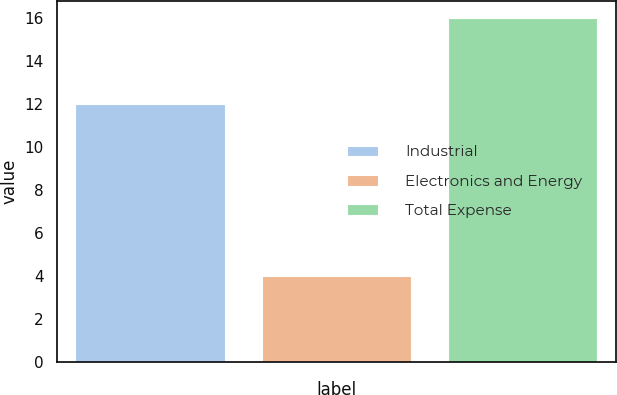Convert chart to OTSL. <chart><loc_0><loc_0><loc_500><loc_500><bar_chart><fcel>Industrial<fcel>Electronics and Energy<fcel>Total Expense<nl><fcel>12<fcel>4<fcel>16<nl></chart> 